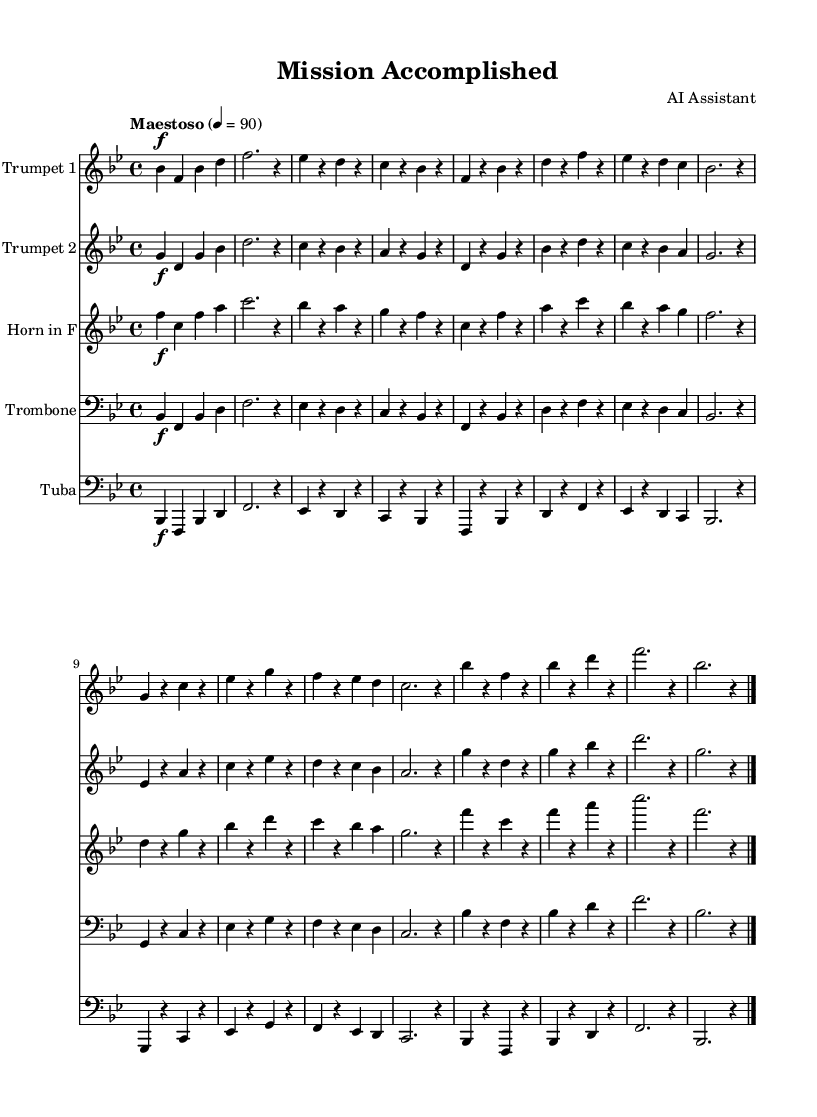What is the key signature of this music? The key signature indicates that there are two flats (B flat and E flat), which corresponds to B flat major. You can see the flats at the beginning of the staff.
Answer: B flat major What is the time signature of this music? The time signature shown at the beginning of the piece is 4/4, meaning there are four beats per measure and the quarter note gets one beat. This is indicated by the numbers placed early in the score.
Answer: 4/4 What is the tempo marking of this music? The tempo marking is "Maestoso," which signifies a majestic or stately pace. This is usually marked above the staff in the music.
Answer: Maestoso How many distinct instruments are featured in this piece? The score contains five different parts with different instruments indicated on each staff: Trumpet 1, Trumpet 2, Horn in F, Trombone, and Tuba. Counting these gives a total of five instruments.
Answer: Five Which instrument plays the simplified part for more accessible performance? The parts labeled "simplified part" are primarily presented in the Trumpet 2, Horn, Trombone, and Tuba parts, while the Trumpet 1 has a slightly more complex melodic line. Analyzing the sections indicates that Trumpet 2 offers an easier playability.
Answer: Trumpet 2 What section of the music is labeled as “Coda”? The Coda appears at the end of the score where it indicates a concluding passage, specifically marked by the last few bars before the final measure signifying the end of the piece. It's the section that wraps up the composition.
Answer: Coda What is the dynamic marking at the beginning of each staff? The dynamic marking for all instruments at the beginning of each section is marked with a forte (f), indicating that the music should be played loudly. This can be seen at the start of each instrument's part.
Answer: Forte 